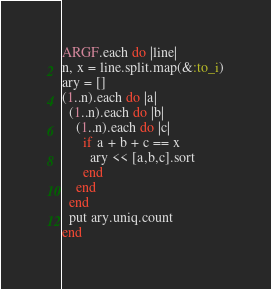Convert code to text. <code><loc_0><loc_0><loc_500><loc_500><_Ruby_>ARGF.each do |line|
n, x = line.split.map(&:to_i)
ary = []
(1..n).each do |a|
  (1..n).each do |b|
    (1..n).each do |c|
      if a + b + c == x
        ary << [a,b,c].sort
      end
    end
  end
  put ary.uniq.count
end</code> 